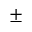Convert formula to latex. <formula><loc_0><loc_0><loc_500><loc_500>\pm</formula> 